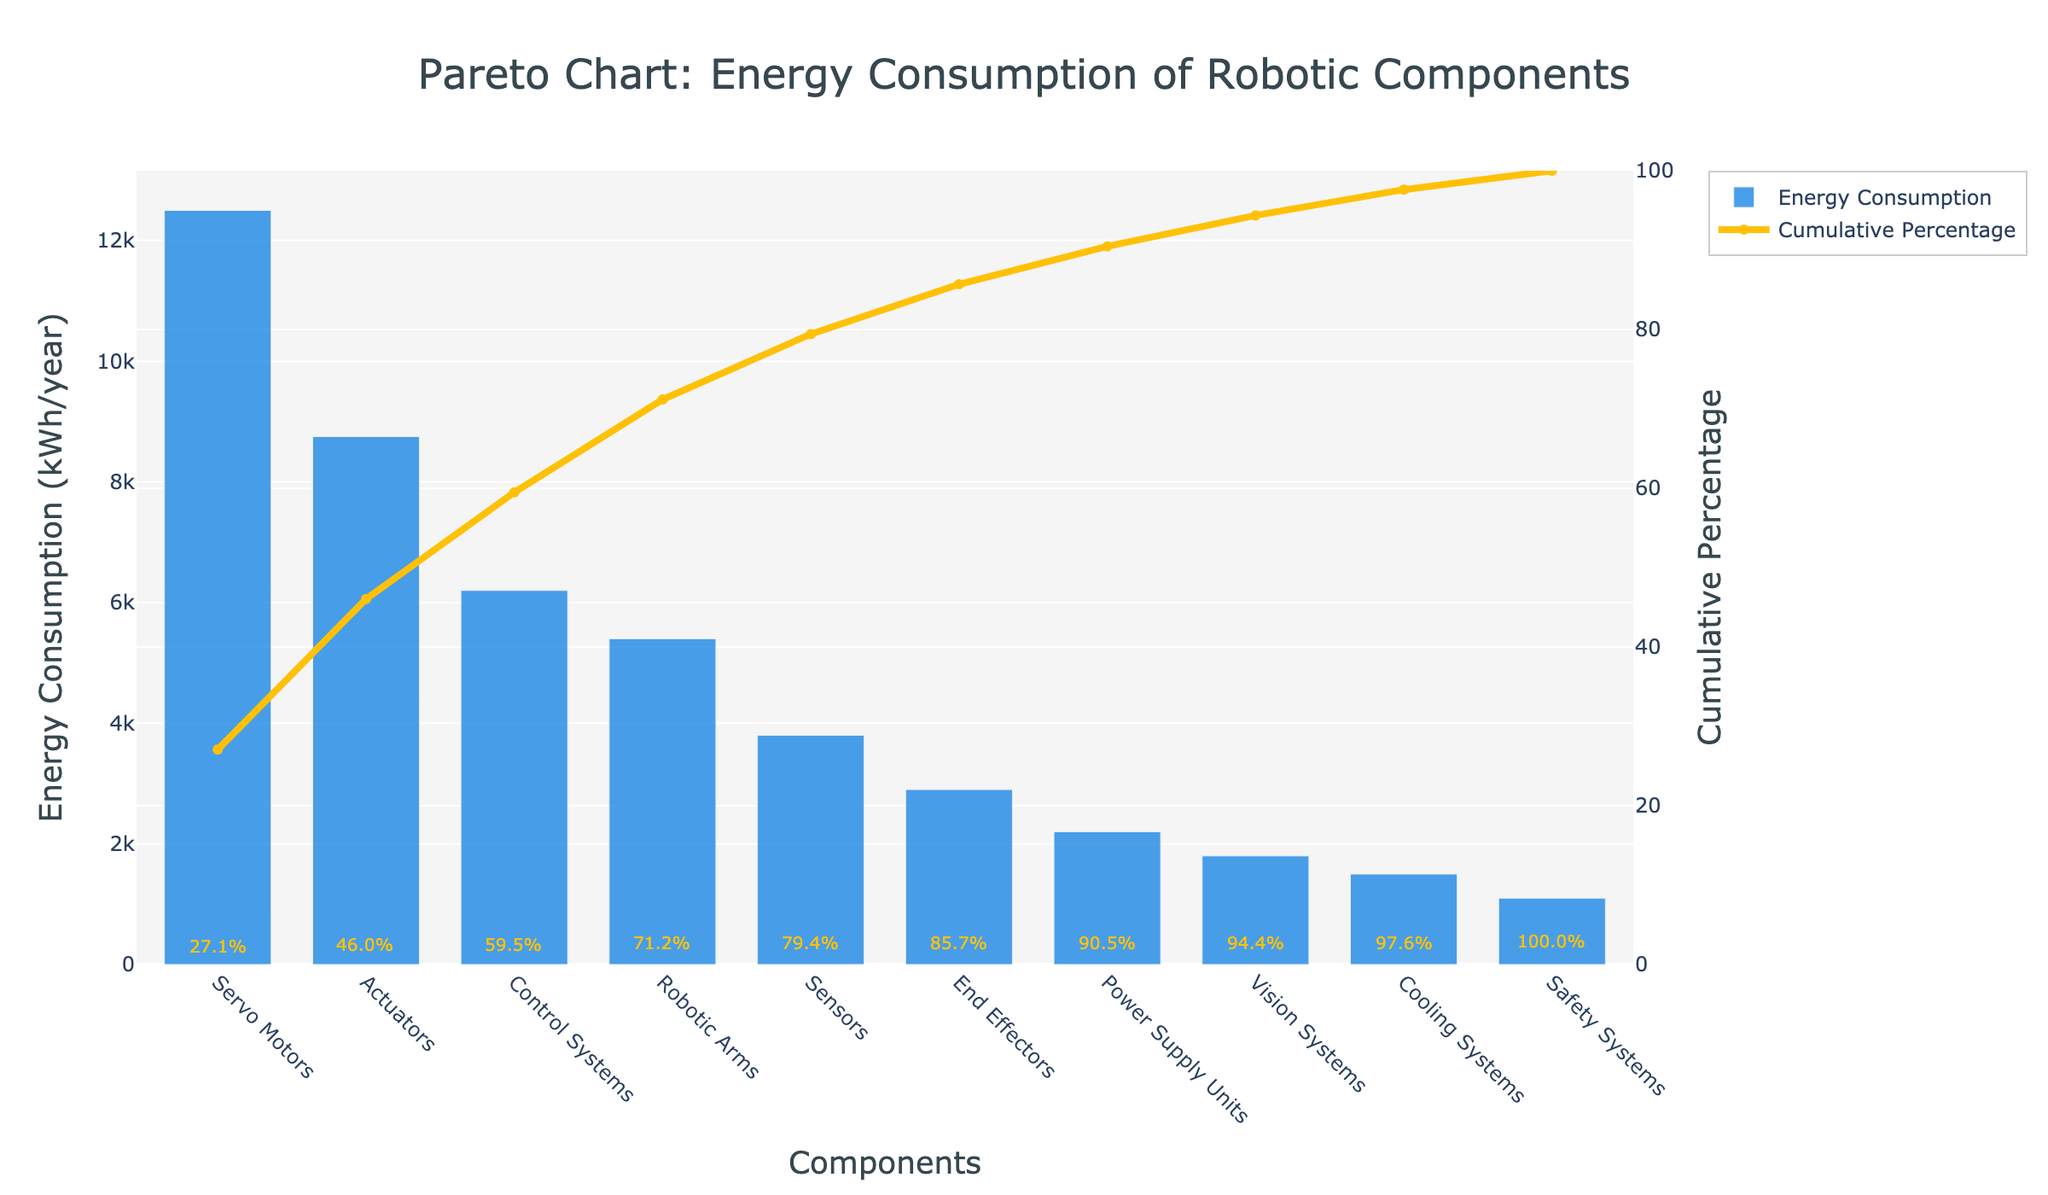What is the title of the plot? The title is usually displayed at the top of the chart, typically centered. The plot has the title "Pareto Chart: Energy Consumption of Robotic Components" at the top.
Answer: Pareto Chart: Energy Consumption of Robotic Components Which component has the highest energy consumption? The highest bar in the chart represents the component with the highest energy consumption. This bar corresponds to "Servo Motors" with an energy consumption of 12500 kWh/year.
Answer: Servo Motors How many components have their energy consumption over 5000 kWh/year? Looking at the height of the bars and their respective labels, we count bars with values over 5000 kWh/year: Servo Motors (12500), Actuators (8750), Control Systems (6200), Robotic Arms (5400).
Answer: Four What is the cumulative percentage of energy consumption after the first three components? The first three components listed are Servo Motors, Actuators, and Control Systems. Their cumulative percentages are shown on the line plot: Servo Motors (~25%), Actuators (~47%), and Control Systems (~60%).
Answer: Around 60% Which component represents the smallest individual energy consumption, and what is its value? The shortest bar in the chart represents the component with the smallest energy consumption. This bar corresponds to "Safety Systems" with 1100 kWh/year.
Answer: Safety Systems at 1100 kWh/year Is the cumulative percentage for the top four components greater than or less than 75%? The cumulative percentage for the top four components (Servo Motors, Actuators, Control Systems, and Robotic Arms) is marked on the line graph. The fourth component, Robotic Arms, shows a cumulative percentage just above 75%.
Answer: Greater than 75% How many components are needed to reach a cumulative energy consumption of about 90%? By following the cumulative percentage line until it crosses the 90% mark, we see that "Vision Systems" (the eighth component) helps reach this level.
Answer: Eight What is the energy consumption difference between the Control Systems and End Effectors? For Control Systems, the energy consumption is 6200 kWh/year, and for End Effectors, it's 2900 kWh/year. The difference is calculated as 6200 - 2900.
Answer: 3300 kWh/year Which components have a cumulative percentage over 50%? By examining the cumulative percentage line, components exceeding 50% are Actuators (second component) and all subsequent components swapped before 60%.
Answer: Control Systems and all previous components What is the energy consumption of Power Supply Units, and how does it compare to Sensors? Power Supply Units have an energy consumption of 2200 kWh/year, while Sensors have 3800 kWh/year. 2200 is less than 3800, so Power Supply Units consume less energy.
Answer: 2200 kWh/year, less than Sensors 